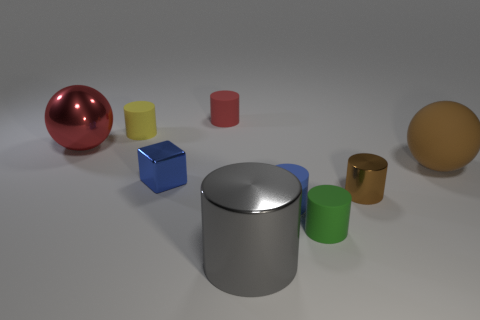What shape is the matte thing that is in front of the tiny red cylinder and to the left of the gray object?
Your answer should be very brief. Cylinder. How many large red metal things are the same shape as the green thing?
Your response must be concise. 0. What size is the gray object that is made of the same material as the big red object?
Your response must be concise. Large. Is the number of small red cylinders greater than the number of blue balls?
Keep it short and to the point. Yes. There is a small metal object to the left of the small metal cylinder; what color is it?
Give a very brief answer. Blue. There is a matte object that is both behind the small blue metal object and to the right of the gray shiny thing; what size is it?
Give a very brief answer. Large. How many brown cubes are the same size as the green rubber object?
Offer a terse response. 0. There is a green thing that is the same shape as the small brown metallic object; what is its material?
Your response must be concise. Rubber. Is the tiny brown thing the same shape as the gray shiny thing?
Your answer should be compact. Yes. How many blue metallic things are in front of the metallic ball?
Make the answer very short. 1. 